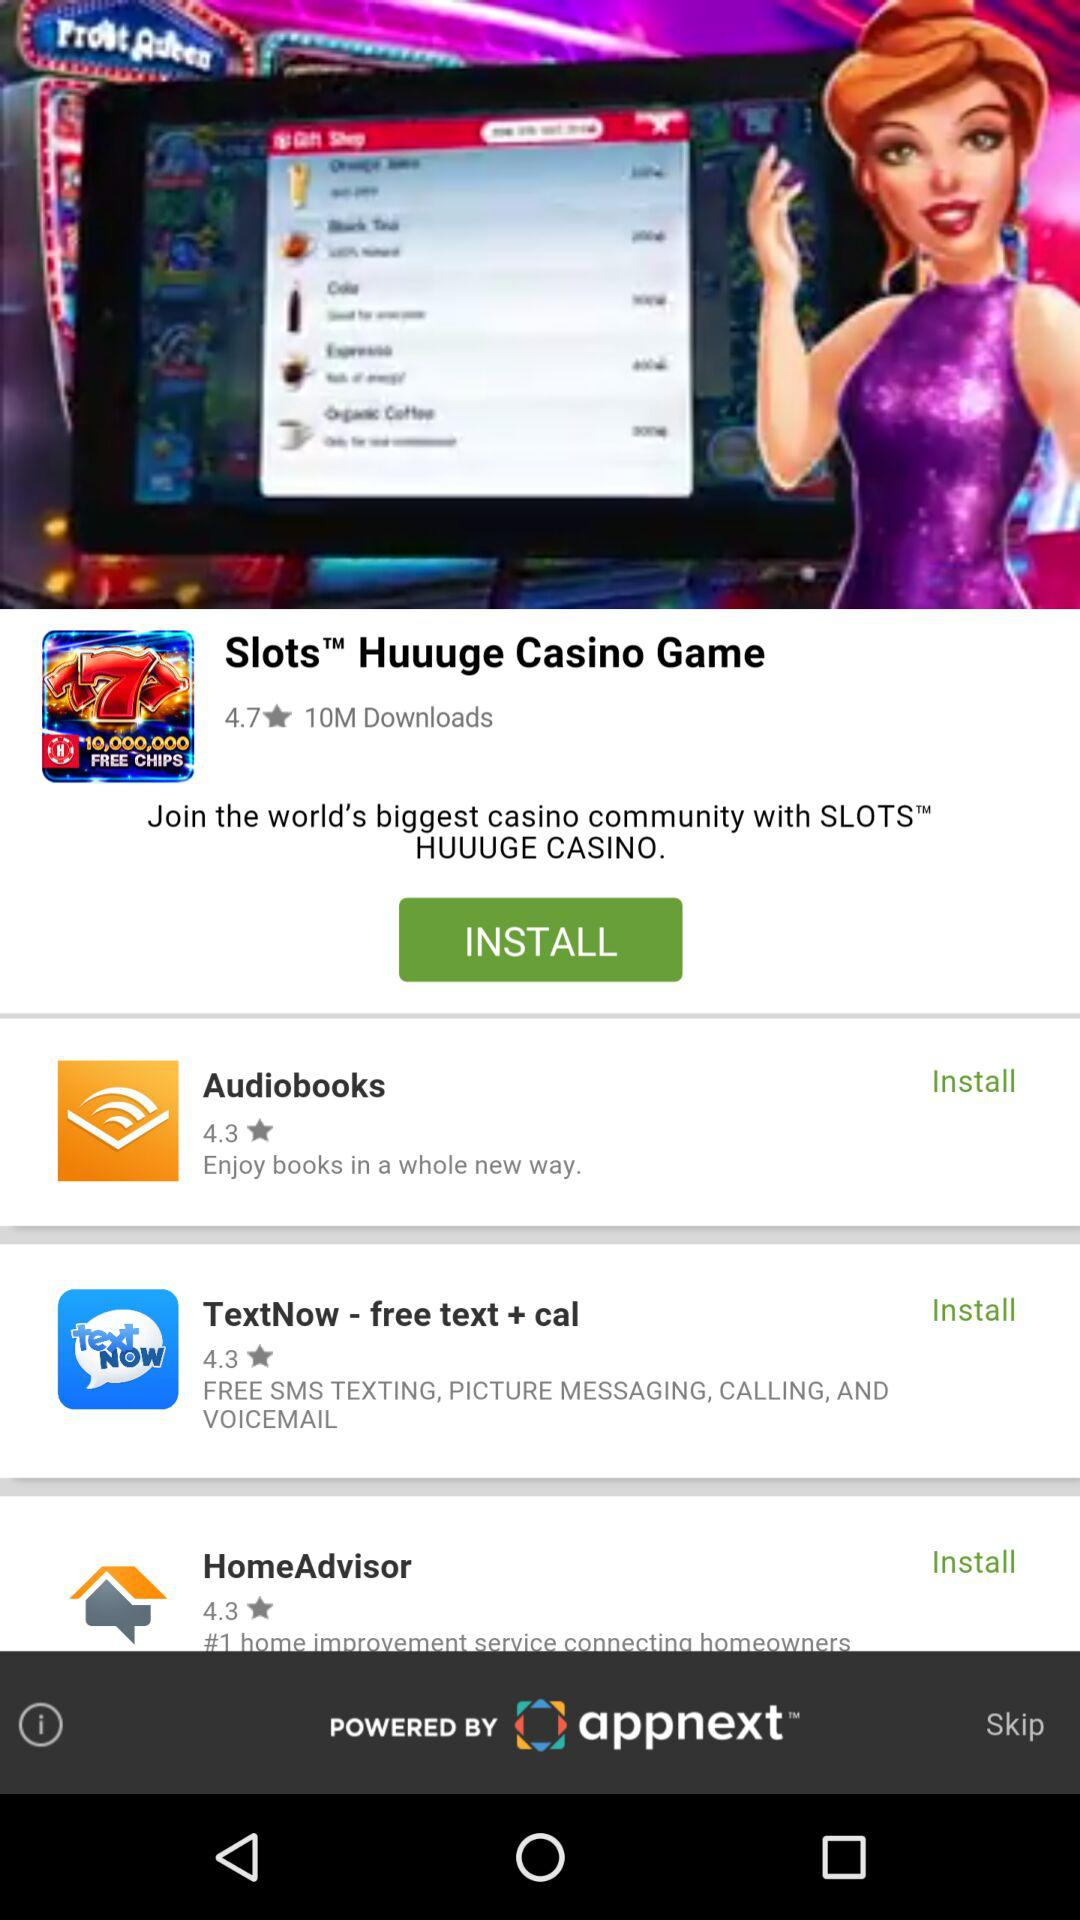What is the rating of the Huuuge Casino Game? The rating is 4.7. 